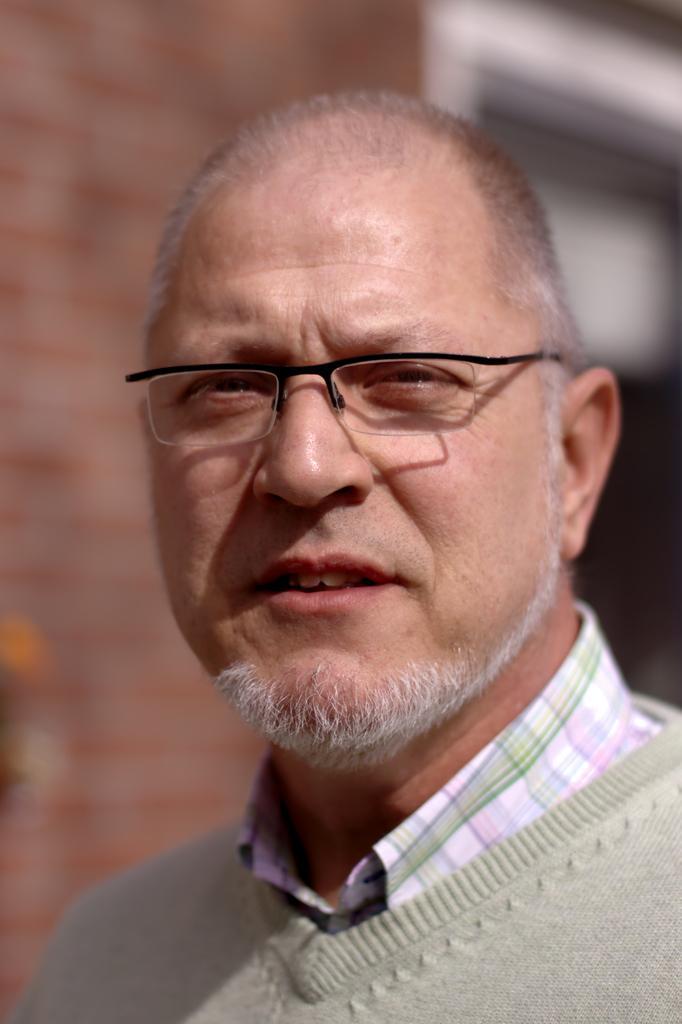Describe this image in one or two sentences. This person wore spectacles and looking forward. Background it is blurry and we can see wall. 